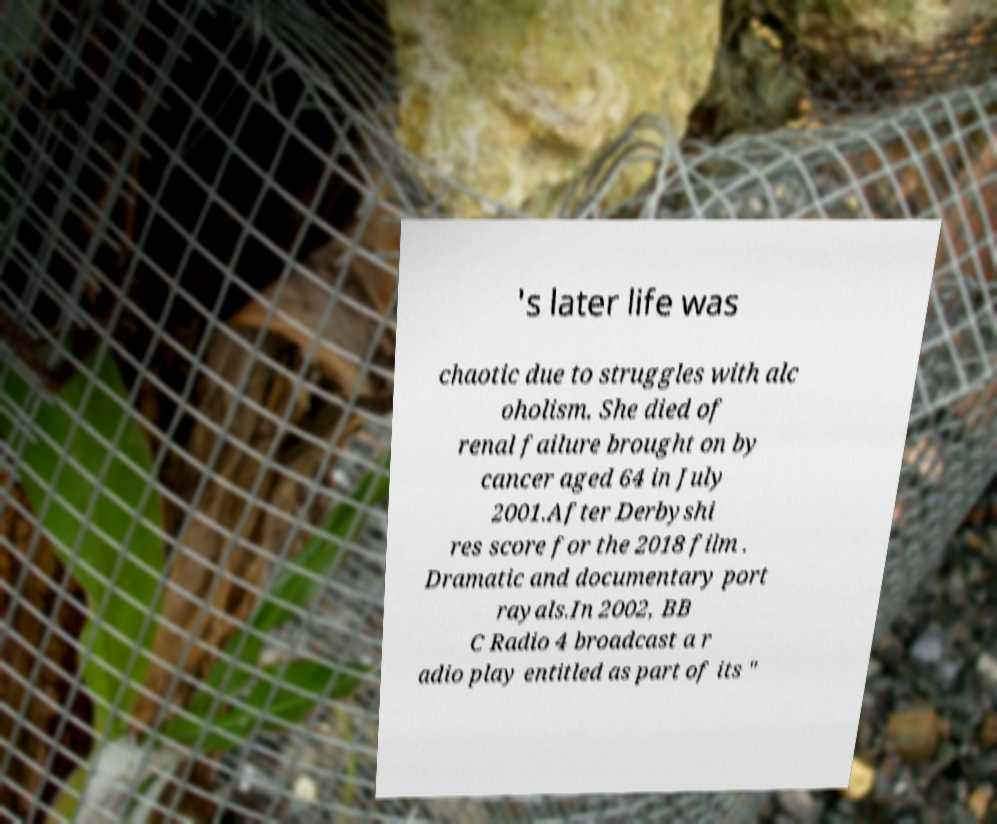Can you accurately transcribe the text from the provided image for me? 's later life was chaotic due to struggles with alc oholism. She died of renal failure brought on by cancer aged 64 in July 2001.After Derbyshi res score for the 2018 film . Dramatic and documentary port rayals.In 2002, BB C Radio 4 broadcast a r adio play entitled as part of its " 